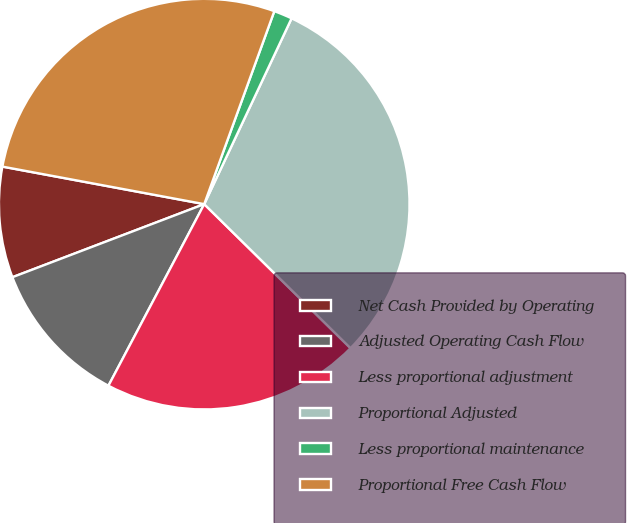Convert chart to OTSL. <chart><loc_0><loc_0><loc_500><loc_500><pie_chart><fcel>Net Cash Provided by Operating<fcel>Adjusted Operating Cash Flow<fcel>Less proportional adjustment<fcel>Proportional Adjusted<fcel>Less proportional maintenance<fcel>Proportional Free Cash Flow<nl><fcel>8.72%<fcel>11.48%<fcel>20.35%<fcel>30.38%<fcel>1.45%<fcel>27.62%<nl></chart> 